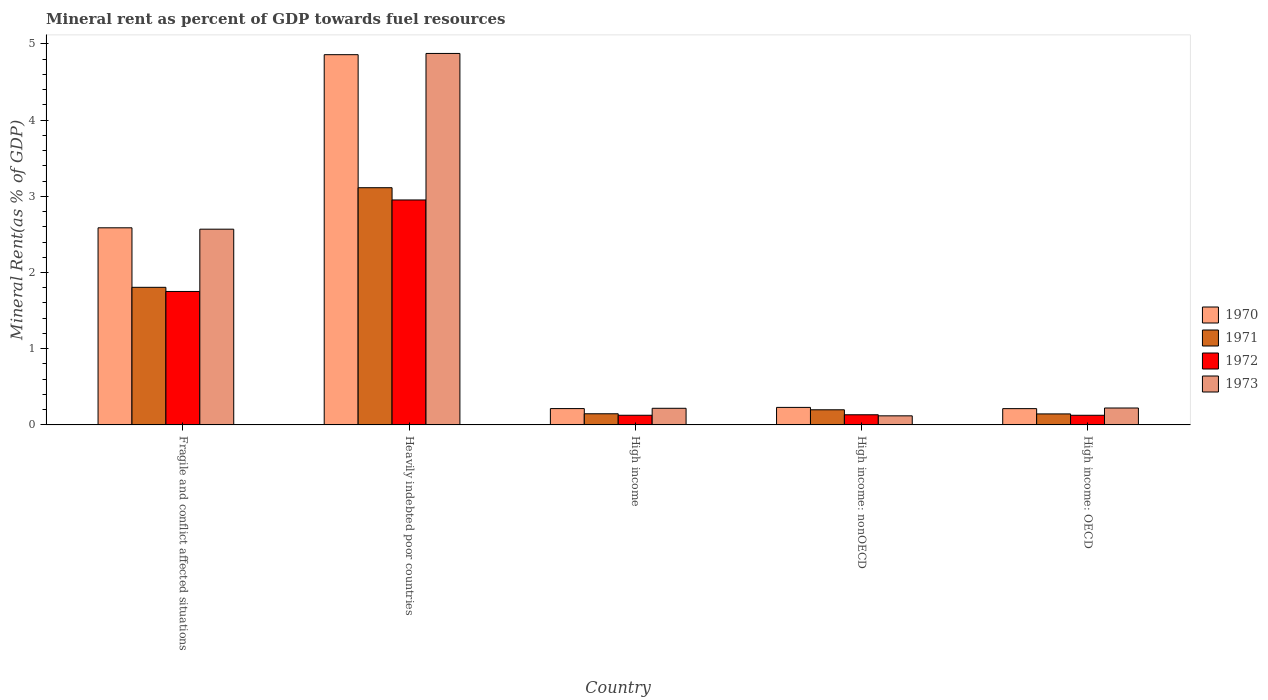How many groups of bars are there?
Ensure brevity in your answer.  5. Are the number of bars on each tick of the X-axis equal?
Offer a very short reply. Yes. How many bars are there on the 4th tick from the left?
Your answer should be compact. 4. What is the label of the 4th group of bars from the left?
Ensure brevity in your answer.  High income: nonOECD. What is the mineral rent in 1970 in High income: OECD?
Provide a succinct answer. 0.21. Across all countries, what is the maximum mineral rent in 1973?
Ensure brevity in your answer.  4.87. Across all countries, what is the minimum mineral rent in 1972?
Provide a short and direct response. 0.13. In which country was the mineral rent in 1973 maximum?
Provide a succinct answer. Heavily indebted poor countries. In which country was the mineral rent in 1970 minimum?
Your answer should be compact. High income: OECD. What is the total mineral rent in 1973 in the graph?
Keep it short and to the point. 8. What is the difference between the mineral rent in 1973 in Fragile and conflict affected situations and that in High income: OECD?
Offer a very short reply. 2.35. What is the difference between the mineral rent in 1972 in High income and the mineral rent in 1971 in Heavily indebted poor countries?
Ensure brevity in your answer.  -2.99. What is the average mineral rent in 1973 per country?
Provide a succinct answer. 1.6. What is the difference between the mineral rent of/in 1971 and mineral rent of/in 1973 in High income?
Provide a succinct answer. -0.07. What is the ratio of the mineral rent in 1971 in Fragile and conflict affected situations to that in High income: nonOECD?
Your response must be concise. 9.09. Is the mineral rent in 1972 in Heavily indebted poor countries less than that in High income: nonOECD?
Give a very brief answer. No. Is the difference between the mineral rent in 1971 in Heavily indebted poor countries and High income: OECD greater than the difference between the mineral rent in 1973 in Heavily indebted poor countries and High income: OECD?
Your response must be concise. No. What is the difference between the highest and the second highest mineral rent in 1971?
Your response must be concise. -1.61. What is the difference between the highest and the lowest mineral rent in 1973?
Your answer should be very brief. 4.75. In how many countries, is the mineral rent in 1973 greater than the average mineral rent in 1973 taken over all countries?
Offer a very short reply. 2. Is the sum of the mineral rent in 1970 in Fragile and conflict affected situations and Heavily indebted poor countries greater than the maximum mineral rent in 1973 across all countries?
Provide a succinct answer. Yes. What does the 1st bar from the right in High income represents?
Your answer should be compact. 1973. Is it the case that in every country, the sum of the mineral rent in 1971 and mineral rent in 1972 is greater than the mineral rent in 1970?
Offer a terse response. Yes. How many bars are there?
Keep it short and to the point. 20. Are all the bars in the graph horizontal?
Provide a short and direct response. No. How many countries are there in the graph?
Keep it short and to the point. 5. What is the difference between two consecutive major ticks on the Y-axis?
Offer a terse response. 1. Does the graph contain any zero values?
Make the answer very short. No. Does the graph contain grids?
Offer a terse response. No. Where does the legend appear in the graph?
Your answer should be very brief. Center right. How many legend labels are there?
Provide a short and direct response. 4. What is the title of the graph?
Make the answer very short. Mineral rent as percent of GDP towards fuel resources. What is the label or title of the Y-axis?
Your response must be concise. Mineral Rent(as % of GDP). What is the Mineral Rent(as % of GDP) in 1970 in Fragile and conflict affected situations?
Your answer should be very brief. 2.59. What is the Mineral Rent(as % of GDP) of 1971 in Fragile and conflict affected situations?
Offer a terse response. 1.81. What is the Mineral Rent(as % of GDP) of 1972 in Fragile and conflict affected situations?
Provide a succinct answer. 1.75. What is the Mineral Rent(as % of GDP) in 1973 in Fragile and conflict affected situations?
Give a very brief answer. 2.57. What is the Mineral Rent(as % of GDP) in 1970 in Heavily indebted poor countries?
Your answer should be compact. 4.86. What is the Mineral Rent(as % of GDP) in 1971 in Heavily indebted poor countries?
Provide a succinct answer. 3.11. What is the Mineral Rent(as % of GDP) in 1972 in Heavily indebted poor countries?
Provide a succinct answer. 2.95. What is the Mineral Rent(as % of GDP) in 1973 in Heavily indebted poor countries?
Keep it short and to the point. 4.87. What is the Mineral Rent(as % of GDP) in 1970 in High income?
Provide a short and direct response. 0.21. What is the Mineral Rent(as % of GDP) in 1971 in High income?
Offer a terse response. 0.15. What is the Mineral Rent(as % of GDP) of 1972 in High income?
Ensure brevity in your answer.  0.13. What is the Mineral Rent(as % of GDP) in 1973 in High income?
Provide a succinct answer. 0.22. What is the Mineral Rent(as % of GDP) in 1970 in High income: nonOECD?
Offer a terse response. 0.23. What is the Mineral Rent(as % of GDP) of 1971 in High income: nonOECD?
Provide a short and direct response. 0.2. What is the Mineral Rent(as % of GDP) in 1972 in High income: nonOECD?
Your response must be concise. 0.13. What is the Mineral Rent(as % of GDP) in 1973 in High income: nonOECD?
Ensure brevity in your answer.  0.12. What is the Mineral Rent(as % of GDP) in 1970 in High income: OECD?
Offer a terse response. 0.21. What is the Mineral Rent(as % of GDP) in 1971 in High income: OECD?
Your answer should be compact. 0.14. What is the Mineral Rent(as % of GDP) in 1972 in High income: OECD?
Ensure brevity in your answer.  0.13. What is the Mineral Rent(as % of GDP) of 1973 in High income: OECD?
Your response must be concise. 0.22. Across all countries, what is the maximum Mineral Rent(as % of GDP) in 1970?
Offer a terse response. 4.86. Across all countries, what is the maximum Mineral Rent(as % of GDP) of 1971?
Your answer should be compact. 3.11. Across all countries, what is the maximum Mineral Rent(as % of GDP) of 1972?
Give a very brief answer. 2.95. Across all countries, what is the maximum Mineral Rent(as % of GDP) of 1973?
Give a very brief answer. 4.87. Across all countries, what is the minimum Mineral Rent(as % of GDP) of 1970?
Provide a short and direct response. 0.21. Across all countries, what is the minimum Mineral Rent(as % of GDP) of 1971?
Keep it short and to the point. 0.14. Across all countries, what is the minimum Mineral Rent(as % of GDP) of 1972?
Your answer should be very brief. 0.13. Across all countries, what is the minimum Mineral Rent(as % of GDP) of 1973?
Your response must be concise. 0.12. What is the total Mineral Rent(as % of GDP) of 1970 in the graph?
Your answer should be very brief. 8.1. What is the total Mineral Rent(as % of GDP) in 1971 in the graph?
Give a very brief answer. 5.41. What is the total Mineral Rent(as % of GDP) of 1972 in the graph?
Make the answer very short. 5.09. What is the total Mineral Rent(as % of GDP) of 1973 in the graph?
Keep it short and to the point. 8. What is the difference between the Mineral Rent(as % of GDP) of 1970 in Fragile and conflict affected situations and that in Heavily indebted poor countries?
Offer a terse response. -2.27. What is the difference between the Mineral Rent(as % of GDP) in 1971 in Fragile and conflict affected situations and that in Heavily indebted poor countries?
Your response must be concise. -1.31. What is the difference between the Mineral Rent(as % of GDP) of 1972 in Fragile and conflict affected situations and that in Heavily indebted poor countries?
Your answer should be very brief. -1.2. What is the difference between the Mineral Rent(as % of GDP) in 1973 in Fragile and conflict affected situations and that in Heavily indebted poor countries?
Provide a short and direct response. -2.31. What is the difference between the Mineral Rent(as % of GDP) of 1970 in Fragile and conflict affected situations and that in High income?
Give a very brief answer. 2.37. What is the difference between the Mineral Rent(as % of GDP) of 1971 in Fragile and conflict affected situations and that in High income?
Ensure brevity in your answer.  1.66. What is the difference between the Mineral Rent(as % of GDP) in 1972 in Fragile and conflict affected situations and that in High income?
Ensure brevity in your answer.  1.62. What is the difference between the Mineral Rent(as % of GDP) in 1973 in Fragile and conflict affected situations and that in High income?
Offer a terse response. 2.35. What is the difference between the Mineral Rent(as % of GDP) of 1970 in Fragile and conflict affected situations and that in High income: nonOECD?
Provide a short and direct response. 2.36. What is the difference between the Mineral Rent(as % of GDP) of 1971 in Fragile and conflict affected situations and that in High income: nonOECD?
Offer a very short reply. 1.61. What is the difference between the Mineral Rent(as % of GDP) of 1972 in Fragile and conflict affected situations and that in High income: nonOECD?
Your answer should be compact. 1.62. What is the difference between the Mineral Rent(as % of GDP) of 1973 in Fragile and conflict affected situations and that in High income: nonOECD?
Provide a succinct answer. 2.45. What is the difference between the Mineral Rent(as % of GDP) of 1970 in Fragile and conflict affected situations and that in High income: OECD?
Your response must be concise. 2.37. What is the difference between the Mineral Rent(as % of GDP) in 1971 in Fragile and conflict affected situations and that in High income: OECD?
Make the answer very short. 1.66. What is the difference between the Mineral Rent(as % of GDP) of 1972 in Fragile and conflict affected situations and that in High income: OECD?
Your answer should be compact. 1.62. What is the difference between the Mineral Rent(as % of GDP) of 1973 in Fragile and conflict affected situations and that in High income: OECD?
Ensure brevity in your answer.  2.35. What is the difference between the Mineral Rent(as % of GDP) in 1970 in Heavily indebted poor countries and that in High income?
Provide a succinct answer. 4.64. What is the difference between the Mineral Rent(as % of GDP) of 1971 in Heavily indebted poor countries and that in High income?
Your response must be concise. 2.97. What is the difference between the Mineral Rent(as % of GDP) of 1972 in Heavily indebted poor countries and that in High income?
Give a very brief answer. 2.82. What is the difference between the Mineral Rent(as % of GDP) of 1973 in Heavily indebted poor countries and that in High income?
Your response must be concise. 4.66. What is the difference between the Mineral Rent(as % of GDP) of 1970 in Heavily indebted poor countries and that in High income: nonOECD?
Your answer should be compact. 4.63. What is the difference between the Mineral Rent(as % of GDP) in 1971 in Heavily indebted poor countries and that in High income: nonOECD?
Give a very brief answer. 2.91. What is the difference between the Mineral Rent(as % of GDP) in 1972 in Heavily indebted poor countries and that in High income: nonOECD?
Offer a very short reply. 2.82. What is the difference between the Mineral Rent(as % of GDP) of 1973 in Heavily indebted poor countries and that in High income: nonOECD?
Offer a very short reply. 4.75. What is the difference between the Mineral Rent(as % of GDP) in 1970 in Heavily indebted poor countries and that in High income: OECD?
Keep it short and to the point. 4.64. What is the difference between the Mineral Rent(as % of GDP) in 1971 in Heavily indebted poor countries and that in High income: OECD?
Keep it short and to the point. 2.97. What is the difference between the Mineral Rent(as % of GDP) in 1972 in Heavily indebted poor countries and that in High income: OECD?
Your answer should be very brief. 2.83. What is the difference between the Mineral Rent(as % of GDP) in 1973 in Heavily indebted poor countries and that in High income: OECD?
Your answer should be very brief. 4.65. What is the difference between the Mineral Rent(as % of GDP) in 1970 in High income and that in High income: nonOECD?
Your response must be concise. -0.02. What is the difference between the Mineral Rent(as % of GDP) in 1971 in High income and that in High income: nonOECD?
Your answer should be very brief. -0.05. What is the difference between the Mineral Rent(as % of GDP) in 1972 in High income and that in High income: nonOECD?
Offer a very short reply. -0.01. What is the difference between the Mineral Rent(as % of GDP) in 1973 in High income and that in High income: nonOECD?
Your answer should be compact. 0.1. What is the difference between the Mineral Rent(as % of GDP) in 1970 in High income and that in High income: OECD?
Your response must be concise. 0. What is the difference between the Mineral Rent(as % of GDP) in 1971 in High income and that in High income: OECD?
Keep it short and to the point. 0. What is the difference between the Mineral Rent(as % of GDP) of 1973 in High income and that in High income: OECD?
Keep it short and to the point. -0. What is the difference between the Mineral Rent(as % of GDP) of 1970 in High income: nonOECD and that in High income: OECD?
Your response must be concise. 0.02. What is the difference between the Mineral Rent(as % of GDP) of 1971 in High income: nonOECD and that in High income: OECD?
Offer a terse response. 0.05. What is the difference between the Mineral Rent(as % of GDP) in 1972 in High income: nonOECD and that in High income: OECD?
Your response must be concise. 0.01. What is the difference between the Mineral Rent(as % of GDP) in 1973 in High income: nonOECD and that in High income: OECD?
Ensure brevity in your answer.  -0.1. What is the difference between the Mineral Rent(as % of GDP) of 1970 in Fragile and conflict affected situations and the Mineral Rent(as % of GDP) of 1971 in Heavily indebted poor countries?
Provide a succinct answer. -0.53. What is the difference between the Mineral Rent(as % of GDP) of 1970 in Fragile and conflict affected situations and the Mineral Rent(as % of GDP) of 1972 in Heavily indebted poor countries?
Offer a terse response. -0.37. What is the difference between the Mineral Rent(as % of GDP) in 1970 in Fragile and conflict affected situations and the Mineral Rent(as % of GDP) in 1973 in Heavily indebted poor countries?
Offer a very short reply. -2.29. What is the difference between the Mineral Rent(as % of GDP) in 1971 in Fragile and conflict affected situations and the Mineral Rent(as % of GDP) in 1972 in Heavily indebted poor countries?
Your answer should be very brief. -1.15. What is the difference between the Mineral Rent(as % of GDP) in 1971 in Fragile and conflict affected situations and the Mineral Rent(as % of GDP) in 1973 in Heavily indebted poor countries?
Your answer should be very brief. -3.07. What is the difference between the Mineral Rent(as % of GDP) of 1972 in Fragile and conflict affected situations and the Mineral Rent(as % of GDP) of 1973 in Heavily indebted poor countries?
Make the answer very short. -3.12. What is the difference between the Mineral Rent(as % of GDP) of 1970 in Fragile and conflict affected situations and the Mineral Rent(as % of GDP) of 1971 in High income?
Offer a terse response. 2.44. What is the difference between the Mineral Rent(as % of GDP) in 1970 in Fragile and conflict affected situations and the Mineral Rent(as % of GDP) in 1972 in High income?
Ensure brevity in your answer.  2.46. What is the difference between the Mineral Rent(as % of GDP) of 1970 in Fragile and conflict affected situations and the Mineral Rent(as % of GDP) of 1973 in High income?
Ensure brevity in your answer.  2.37. What is the difference between the Mineral Rent(as % of GDP) of 1971 in Fragile and conflict affected situations and the Mineral Rent(as % of GDP) of 1972 in High income?
Your answer should be very brief. 1.68. What is the difference between the Mineral Rent(as % of GDP) of 1971 in Fragile and conflict affected situations and the Mineral Rent(as % of GDP) of 1973 in High income?
Offer a terse response. 1.59. What is the difference between the Mineral Rent(as % of GDP) of 1972 in Fragile and conflict affected situations and the Mineral Rent(as % of GDP) of 1973 in High income?
Your answer should be very brief. 1.53. What is the difference between the Mineral Rent(as % of GDP) in 1970 in Fragile and conflict affected situations and the Mineral Rent(as % of GDP) in 1971 in High income: nonOECD?
Your response must be concise. 2.39. What is the difference between the Mineral Rent(as % of GDP) in 1970 in Fragile and conflict affected situations and the Mineral Rent(as % of GDP) in 1972 in High income: nonOECD?
Provide a succinct answer. 2.45. What is the difference between the Mineral Rent(as % of GDP) in 1970 in Fragile and conflict affected situations and the Mineral Rent(as % of GDP) in 1973 in High income: nonOECD?
Provide a short and direct response. 2.47. What is the difference between the Mineral Rent(as % of GDP) in 1971 in Fragile and conflict affected situations and the Mineral Rent(as % of GDP) in 1972 in High income: nonOECD?
Keep it short and to the point. 1.67. What is the difference between the Mineral Rent(as % of GDP) of 1971 in Fragile and conflict affected situations and the Mineral Rent(as % of GDP) of 1973 in High income: nonOECD?
Your answer should be compact. 1.69. What is the difference between the Mineral Rent(as % of GDP) of 1972 in Fragile and conflict affected situations and the Mineral Rent(as % of GDP) of 1973 in High income: nonOECD?
Provide a short and direct response. 1.63. What is the difference between the Mineral Rent(as % of GDP) of 1970 in Fragile and conflict affected situations and the Mineral Rent(as % of GDP) of 1971 in High income: OECD?
Ensure brevity in your answer.  2.44. What is the difference between the Mineral Rent(as % of GDP) in 1970 in Fragile and conflict affected situations and the Mineral Rent(as % of GDP) in 1972 in High income: OECD?
Your answer should be compact. 2.46. What is the difference between the Mineral Rent(as % of GDP) of 1970 in Fragile and conflict affected situations and the Mineral Rent(as % of GDP) of 1973 in High income: OECD?
Your answer should be compact. 2.36. What is the difference between the Mineral Rent(as % of GDP) of 1971 in Fragile and conflict affected situations and the Mineral Rent(as % of GDP) of 1972 in High income: OECD?
Give a very brief answer. 1.68. What is the difference between the Mineral Rent(as % of GDP) of 1971 in Fragile and conflict affected situations and the Mineral Rent(as % of GDP) of 1973 in High income: OECD?
Offer a very short reply. 1.58. What is the difference between the Mineral Rent(as % of GDP) in 1972 in Fragile and conflict affected situations and the Mineral Rent(as % of GDP) in 1973 in High income: OECD?
Ensure brevity in your answer.  1.53. What is the difference between the Mineral Rent(as % of GDP) of 1970 in Heavily indebted poor countries and the Mineral Rent(as % of GDP) of 1971 in High income?
Your answer should be compact. 4.71. What is the difference between the Mineral Rent(as % of GDP) of 1970 in Heavily indebted poor countries and the Mineral Rent(as % of GDP) of 1972 in High income?
Provide a succinct answer. 4.73. What is the difference between the Mineral Rent(as % of GDP) of 1970 in Heavily indebted poor countries and the Mineral Rent(as % of GDP) of 1973 in High income?
Offer a terse response. 4.64. What is the difference between the Mineral Rent(as % of GDP) of 1971 in Heavily indebted poor countries and the Mineral Rent(as % of GDP) of 1972 in High income?
Provide a short and direct response. 2.99. What is the difference between the Mineral Rent(as % of GDP) of 1971 in Heavily indebted poor countries and the Mineral Rent(as % of GDP) of 1973 in High income?
Ensure brevity in your answer.  2.89. What is the difference between the Mineral Rent(as % of GDP) in 1972 in Heavily indebted poor countries and the Mineral Rent(as % of GDP) in 1973 in High income?
Provide a succinct answer. 2.73. What is the difference between the Mineral Rent(as % of GDP) of 1970 in Heavily indebted poor countries and the Mineral Rent(as % of GDP) of 1971 in High income: nonOECD?
Ensure brevity in your answer.  4.66. What is the difference between the Mineral Rent(as % of GDP) of 1970 in Heavily indebted poor countries and the Mineral Rent(as % of GDP) of 1972 in High income: nonOECD?
Keep it short and to the point. 4.72. What is the difference between the Mineral Rent(as % of GDP) in 1970 in Heavily indebted poor countries and the Mineral Rent(as % of GDP) in 1973 in High income: nonOECD?
Keep it short and to the point. 4.74. What is the difference between the Mineral Rent(as % of GDP) of 1971 in Heavily indebted poor countries and the Mineral Rent(as % of GDP) of 1972 in High income: nonOECD?
Provide a succinct answer. 2.98. What is the difference between the Mineral Rent(as % of GDP) in 1971 in Heavily indebted poor countries and the Mineral Rent(as % of GDP) in 1973 in High income: nonOECD?
Give a very brief answer. 2.99. What is the difference between the Mineral Rent(as % of GDP) of 1972 in Heavily indebted poor countries and the Mineral Rent(as % of GDP) of 1973 in High income: nonOECD?
Offer a terse response. 2.83. What is the difference between the Mineral Rent(as % of GDP) in 1970 in Heavily indebted poor countries and the Mineral Rent(as % of GDP) in 1971 in High income: OECD?
Ensure brevity in your answer.  4.71. What is the difference between the Mineral Rent(as % of GDP) in 1970 in Heavily indebted poor countries and the Mineral Rent(as % of GDP) in 1972 in High income: OECD?
Offer a terse response. 4.73. What is the difference between the Mineral Rent(as % of GDP) of 1970 in Heavily indebted poor countries and the Mineral Rent(as % of GDP) of 1973 in High income: OECD?
Ensure brevity in your answer.  4.64. What is the difference between the Mineral Rent(as % of GDP) in 1971 in Heavily indebted poor countries and the Mineral Rent(as % of GDP) in 1972 in High income: OECD?
Offer a very short reply. 2.99. What is the difference between the Mineral Rent(as % of GDP) of 1971 in Heavily indebted poor countries and the Mineral Rent(as % of GDP) of 1973 in High income: OECD?
Your response must be concise. 2.89. What is the difference between the Mineral Rent(as % of GDP) in 1972 in Heavily indebted poor countries and the Mineral Rent(as % of GDP) in 1973 in High income: OECD?
Offer a very short reply. 2.73. What is the difference between the Mineral Rent(as % of GDP) in 1970 in High income and the Mineral Rent(as % of GDP) in 1971 in High income: nonOECD?
Your response must be concise. 0.02. What is the difference between the Mineral Rent(as % of GDP) of 1970 in High income and the Mineral Rent(as % of GDP) of 1972 in High income: nonOECD?
Offer a very short reply. 0.08. What is the difference between the Mineral Rent(as % of GDP) in 1970 in High income and the Mineral Rent(as % of GDP) in 1973 in High income: nonOECD?
Your answer should be compact. 0.1. What is the difference between the Mineral Rent(as % of GDP) in 1971 in High income and the Mineral Rent(as % of GDP) in 1972 in High income: nonOECD?
Your answer should be compact. 0.01. What is the difference between the Mineral Rent(as % of GDP) in 1971 in High income and the Mineral Rent(as % of GDP) in 1973 in High income: nonOECD?
Your answer should be very brief. 0.03. What is the difference between the Mineral Rent(as % of GDP) of 1972 in High income and the Mineral Rent(as % of GDP) of 1973 in High income: nonOECD?
Offer a very short reply. 0.01. What is the difference between the Mineral Rent(as % of GDP) in 1970 in High income and the Mineral Rent(as % of GDP) in 1971 in High income: OECD?
Offer a very short reply. 0.07. What is the difference between the Mineral Rent(as % of GDP) in 1970 in High income and the Mineral Rent(as % of GDP) in 1972 in High income: OECD?
Make the answer very short. 0.09. What is the difference between the Mineral Rent(as % of GDP) of 1970 in High income and the Mineral Rent(as % of GDP) of 1973 in High income: OECD?
Give a very brief answer. -0.01. What is the difference between the Mineral Rent(as % of GDP) in 1971 in High income and the Mineral Rent(as % of GDP) in 1972 in High income: OECD?
Provide a succinct answer. 0.02. What is the difference between the Mineral Rent(as % of GDP) in 1971 in High income and the Mineral Rent(as % of GDP) in 1973 in High income: OECD?
Give a very brief answer. -0.08. What is the difference between the Mineral Rent(as % of GDP) in 1972 in High income and the Mineral Rent(as % of GDP) in 1973 in High income: OECD?
Offer a very short reply. -0.1. What is the difference between the Mineral Rent(as % of GDP) of 1970 in High income: nonOECD and the Mineral Rent(as % of GDP) of 1971 in High income: OECD?
Give a very brief answer. 0.09. What is the difference between the Mineral Rent(as % of GDP) in 1970 in High income: nonOECD and the Mineral Rent(as % of GDP) in 1972 in High income: OECD?
Make the answer very short. 0.1. What is the difference between the Mineral Rent(as % of GDP) in 1970 in High income: nonOECD and the Mineral Rent(as % of GDP) in 1973 in High income: OECD?
Offer a terse response. 0.01. What is the difference between the Mineral Rent(as % of GDP) in 1971 in High income: nonOECD and the Mineral Rent(as % of GDP) in 1972 in High income: OECD?
Your answer should be compact. 0.07. What is the difference between the Mineral Rent(as % of GDP) of 1971 in High income: nonOECD and the Mineral Rent(as % of GDP) of 1973 in High income: OECD?
Offer a very short reply. -0.02. What is the difference between the Mineral Rent(as % of GDP) in 1972 in High income: nonOECD and the Mineral Rent(as % of GDP) in 1973 in High income: OECD?
Offer a very short reply. -0.09. What is the average Mineral Rent(as % of GDP) of 1970 per country?
Make the answer very short. 1.62. What is the average Mineral Rent(as % of GDP) of 1971 per country?
Keep it short and to the point. 1.08. What is the average Mineral Rent(as % of GDP) of 1972 per country?
Your answer should be compact. 1.02. What is the average Mineral Rent(as % of GDP) of 1973 per country?
Your response must be concise. 1.6. What is the difference between the Mineral Rent(as % of GDP) in 1970 and Mineral Rent(as % of GDP) in 1971 in Fragile and conflict affected situations?
Your answer should be compact. 0.78. What is the difference between the Mineral Rent(as % of GDP) in 1970 and Mineral Rent(as % of GDP) in 1972 in Fragile and conflict affected situations?
Your answer should be very brief. 0.84. What is the difference between the Mineral Rent(as % of GDP) of 1970 and Mineral Rent(as % of GDP) of 1973 in Fragile and conflict affected situations?
Keep it short and to the point. 0.02. What is the difference between the Mineral Rent(as % of GDP) in 1971 and Mineral Rent(as % of GDP) in 1972 in Fragile and conflict affected situations?
Give a very brief answer. 0.05. What is the difference between the Mineral Rent(as % of GDP) of 1971 and Mineral Rent(as % of GDP) of 1973 in Fragile and conflict affected situations?
Ensure brevity in your answer.  -0.76. What is the difference between the Mineral Rent(as % of GDP) of 1972 and Mineral Rent(as % of GDP) of 1973 in Fragile and conflict affected situations?
Ensure brevity in your answer.  -0.82. What is the difference between the Mineral Rent(as % of GDP) in 1970 and Mineral Rent(as % of GDP) in 1971 in Heavily indebted poor countries?
Make the answer very short. 1.75. What is the difference between the Mineral Rent(as % of GDP) of 1970 and Mineral Rent(as % of GDP) of 1972 in Heavily indebted poor countries?
Ensure brevity in your answer.  1.91. What is the difference between the Mineral Rent(as % of GDP) of 1970 and Mineral Rent(as % of GDP) of 1973 in Heavily indebted poor countries?
Your answer should be very brief. -0.02. What is the difference between the Mineral Rent(as % of GDP) of 1971 and Mineral Rent(as % of GDP) of 1972 in Heavily indebted poor countries?
Provide a succinct answer. 0.16. What is the difference between the Mineral Rent(as % of GDP) of 1971 and Mineral Rent(as % of GDP) of 1973 in Heavily indebted poor countries?
Make the answer very short. -1.76. What is the difference between the Mineral Rent(as % of GDP) of 1972 and Mineral Rent(as % of GDP) of 1973 in Heavily indebted poor countries?
Provide a succinct answer. -1.92. What is the difference between the Mineral Rent(as % of GDP) in 1970 and Mineral Rent(as % of GDP) in 1971 in High income?
Ensure brevity in your answer.  0.07. What is the difference between the Mineral Rent(as % of GDP) in 1970 and Mineral Rent(as % of GDP) in 1972 in High income?
Give a very brief answer. 0.09. What is the difference between the Mineral Rent(as % of GDP) in 1970 and Mineral Rent(as % of GDP) in 1973 in High income?
Provide a short and direct response. -0. What is the difference between the Mineral Rent(as % of GDP) of 1971 and Mineral Rent(as % of GDP) of 1972 in High income?
Ensure brevity in your answer.  0.02. What is the difference between the Mineral Rent(as % of GDP) in 1971 and Mineral Rent(as % of GDP) in 1973 in High income?
Your answer should be compact. -0.07. What is the difference between the Mineral Rent(as % of GDP) of 1972 and Mineral Rent(as % of GDP) of 1973 in High income?
Your answer should be very brief. -0.09. What is the difference between the Mineral Rent(as % of GDP) in 1970 and Mineral Rent(as % of GDP) in 1971 in High income: nonOECD?
Offer a very short reply. 0.03. What is the difference between the Mineral Rent(as % of GDP) of 1970 and Mineral Rent(as % of GDP) of 1972 in High income: nonOECD?
Your answer should be very brief. 0.1. What is the difference between the Mineral Rent(as % of GDP) in 1970 and Mineral Rent(as % of GDP) in 1973 in High income: nonOECD?
Give a very brief answer. 0.11. What is the difference between the Mineral Rent(as % of GDP) of 1971 and Mineral Rent(as % of GDP) of 1972 in High income: nonOECD?
Ensure brevity in your answer.  0.07. What is the difference between the Mineral Rent(as % of GDP) of 1971 and Mineral Rent(as % of GDP) of 1973 in High income: nonOECD?
Your answer should be very brief. 0.08. What is the difference between the Mineral Rent(as % of GDP) in 1972 and Mineral Rent(as % of GDP) in 1973 in High income: nonOECD?
Keep it short and to the point. 0.01. What is the difference between the Mineral Rent(as % of GDP) of 1970 and Mineral Rent(as % of GDP) of 1971 in High income: OECD?
Offer a very short reply. 0.07. What is the difference between the Mineral Rent(as % of GDP) of 1970 and Mineral Rent(as % of GDP) of 1972 in High income: OECD?
Your answer should be very brief. 0.09. What is the difference between the Mineral Rent(as % of GDP) in 1970 and Mineral Rent(as % of GDP) in 1973 in High income: OECD?
Your response must be concise. -0.01. What is the difference between the Mineral Rent(as % of GDP) of 1971 and Mineral Rent(as % of GDP) of 1972 in High income: OECD?
Make the answer very short. 0.02. What is the difference between the Mineral Rent(as % of GDP) of 1971 and Mineral Rent(as % of GDP) of 1973 in High income: OECD?
Keep it short and to the point. -0.08. What is the difference between the Mineral Rent(as % of GDP) of 1972 and Mineral Rent(as % of GDP) of 1973 in High income: OECD?
Make the answer very short. -0.1. What is the ratio of the Mineral Rent(as % of GDP) in 1970 in Fragile and conflict affected situations to that in Heavily indebted poor countries?
Your answer should be compact. 0.53. What is the ratio of the Mineral Rent(as % of GDP) in 1971 in Fragile and conflict affected situations to that in Heavily indebted poor countries?
Keep it short and to the point. 0.58. What is the ratio of the Mineral Rent(as % of GDP) of 1972 in Fragile and conflict affected situations to that in Heavily indebted poor countries?
Keep it short and to the point. 0.59. What is the ratio of the Mineral Rent(as % of GDP) of 1973 in Fragile and conflict affected situations to that in Heavily indebted poor countries?
Give a very brief answer. 0.53. What is the ratio of the Mineral Rent(as % of GDP) of 1970 in Fragile and conflict affected situations to that in High income?
Provide a short and direct response. 12.08. What is the ratio of the Mineral Rent(as % of GDP) in 1971 in Fragile and conflict affected situations to that in High income?
Offer a terse response. 12.36. What is the ratio of the Mineral Rent(as % of GDP) of 1972 in Fragile and conflict affected situations to that in High income?
Your answer should be very brief. 13.82. What is the ratio of the Mineral Rent(as % of GDP) in 1973 in Fragile and conflict affected situations to that in High income?
Offer a very short reply. 11.78. What is the ratio of the Mineral Rent(as % of GDP) of 1970 in Fragile and conflict affected situations to that in High income: nonOECD?
Provide a short and direct response. 11.26. What is the ratio of the Mineral Rent(as % of GDP) in 1971 in Fragile and conflict affected situations to that in High income: nonOECD?
Give a very brief answer. 9.09. What is the ratio of the Mineral Rent(as % of GDP) in 1972 in Fragile and conflict affected situations to that in High income: nonOECD?
Your answer should be compact. 13.15. What is the ratio of the Mineral Rent(as % of GDP) in 1973 in Fragile and conflict affected situations to that in High income: nonOECD?
Your response must be concise. 21.58. What is the ratio of the Mineral Rent(as % of GDP) in 1970 in Fragile and conflict affected situations to that in High income: OECD?
Offer a terse response. 12.11. What is the ratio of the Mineral Rent(as % of GDP) in 1971 in Fragile and conflict affected situations to that in High income: OECD?
Provide a succinct answer. 12.51. What is the ratio of the Mineral Rent(as % of GDP) of 1972 in Fragile and conflict affected situations to that in High income: OECD?
Provide a short and direct response. 13.85. What is the ratio of the Mineral Rent(as % of GDP) of 1973 in Fragile and conflict affected situations to that in High income: OECD?
Give a very brief answer. 11.58. What is the ratio of the Mineral Rent(as % of GDP) of 1970 in Heavily indebted poor countries to that in High income?
Your response must be concise. 22.69. What is the ratio of the Mineral Rent(as % of GDP) of 1971 in Heavily indebted poor countries to that in High income?
Make the answer very short. 21.31. What is the ratio of the Mineral Rent(as % of GDP) in 1972 in Heavily indebted poor countries to that in High income?
Offer a terse response. 23.3. What is the ratio of the Mineral Rent(as % of GDP) in 1973 in Heavily indebted poor countries to that in High income?
Offer a very short reply. 22.35. What is the ratio of the Mineral Rent(as % of GDP) of 1970 in Heavily indebted poor countries to that in High income: nonOECD?
Provide a short and direct response. 21.14. What is the ratio of the Mineral Rent(as % of GDP) of 1971 in Heavily indebted poor countries to that in High income: nonOECD?
Make the answer very short. 15.68. What is the ratio of the Mineral Rent(as % of GDP) of 1972 in Heavily indebted poor countries to that in High income: nonOECD?
Offer a very short reply. 22.17. What is the ratio of the Mineral Rent(as % of GDP) in 1973 in Heavily indebted poor countries to that in High income: nonOECD?
Your answer should be very brief. 40.95. What is the ratio of the Mineral Rent(as % of GDP) of 1970 in Heavily indebted poor countries to that in High income: OECD?
Offer a very short reply. 22.74. What is the ratio of the Mineral Rent(as % of GDP) of 1971 in Heavily indebted poor countries to that in High income: OECD?
Your answer should be very brief. 21.57. What is the ratio of the Mineral Rent(as % of GDP) in 1972 in Heavily indebted poor countries to that in High income: OECD?
Keep it short and to the point. 23.34. What is the ratio of the Mineral Rent(as % of GDP) of 1973 in Heavily indebted poor countries to that in High income: OECD?
Offer a terse response. 21.98. What is the ratio of the Mineral Rent(as % of GDP) of 1970 in High income to that in High income: nonOECD?
Ensure brevity in your answer.  0.93. What is the ratio of the Mineral Rent(as % of GDP) in 1971 in High income to that in High income: nonOECD?
Your answer should be compact. 0.74. What is the ratio of the Mineral Rent(as % of GDP) in 1972 in High income to that in High income: nonOECD?
Offer a very short reply. 0.95. What is the ratio of the Mineral Rent(as % of GDP) of 1973 in High income to that in High income: nonOECD?
Make the answer very short. 1.83. What is the ratio of the Mineral Rent(as % of GDP) of 1970 in High income to that in High income: OECD?
Offer a very short reply. 1. What is the ratio of the Mineral Rent(as % of GDP) in 1971 in High income to that in High income: OECD?
Make the answer very short. 1.01. What is the ratio of the Mineral Rent(as % of GDP) in 1973 in High income to that in High income: OECD?
Ensure brevity in your answer.  0.98. What is the ratio of the Mineral Rent(as % of GDP) in 1970 in High income: nonOECD to that in High income: OECD?
Offer a terse response. 1.08. What is the ratio of the Mineral Rent(as % of GDP) of 1971 in High income: nonOECD to that in High income: OECD?
Give a very brief answer. 1.38. What is the ratio of the Mineral Rent(as % of GDP) in 1972 in High income: nonOECD to that in High income: OECD?
Provide a short and direct response. 1.05. What is the ratio of the Mineral Rent(as % of GDP) in 1973 in High income: nonOECD to that in High income: OECD?
Ensure brevity in your answer.  0.54. What is the difference between the highest and the second highest Mineral Rent(as % of GDP) of 1970?
Your response must be concise. 2.27. What is the difference between the highest and the second highest Mineral Rent(as % of GDP) of 1971?
Offer a terse response. 1.31. What is the difference between the highest and the second highest Mineral Rent(as % of GDP) of 1972?
Offer a terse response. 1.2. What is the difference between the highest and the second highest Mineral Rent(as % of GDP) of 1973?
Ensure brevity in your answer.  2.31. What is the difference between the highest and the lowest Mineral Rent(as % of GDP) of 1970?
Provide a succinct answer. 4.64. What is the difference between the highest and the lowest Mineral Rent(as % of GDP) in 1971?
Offer a very short reply. 2.97. What is the difference between the highest and the lowest Mineral Rent(as % of GDP) in 1972?
Provide a succinct answer. 2.83. What is the difference between the highest and the lowest Mineral Rent(as % of GDP) in 1973?
Give a very brief answer. 4.75. 